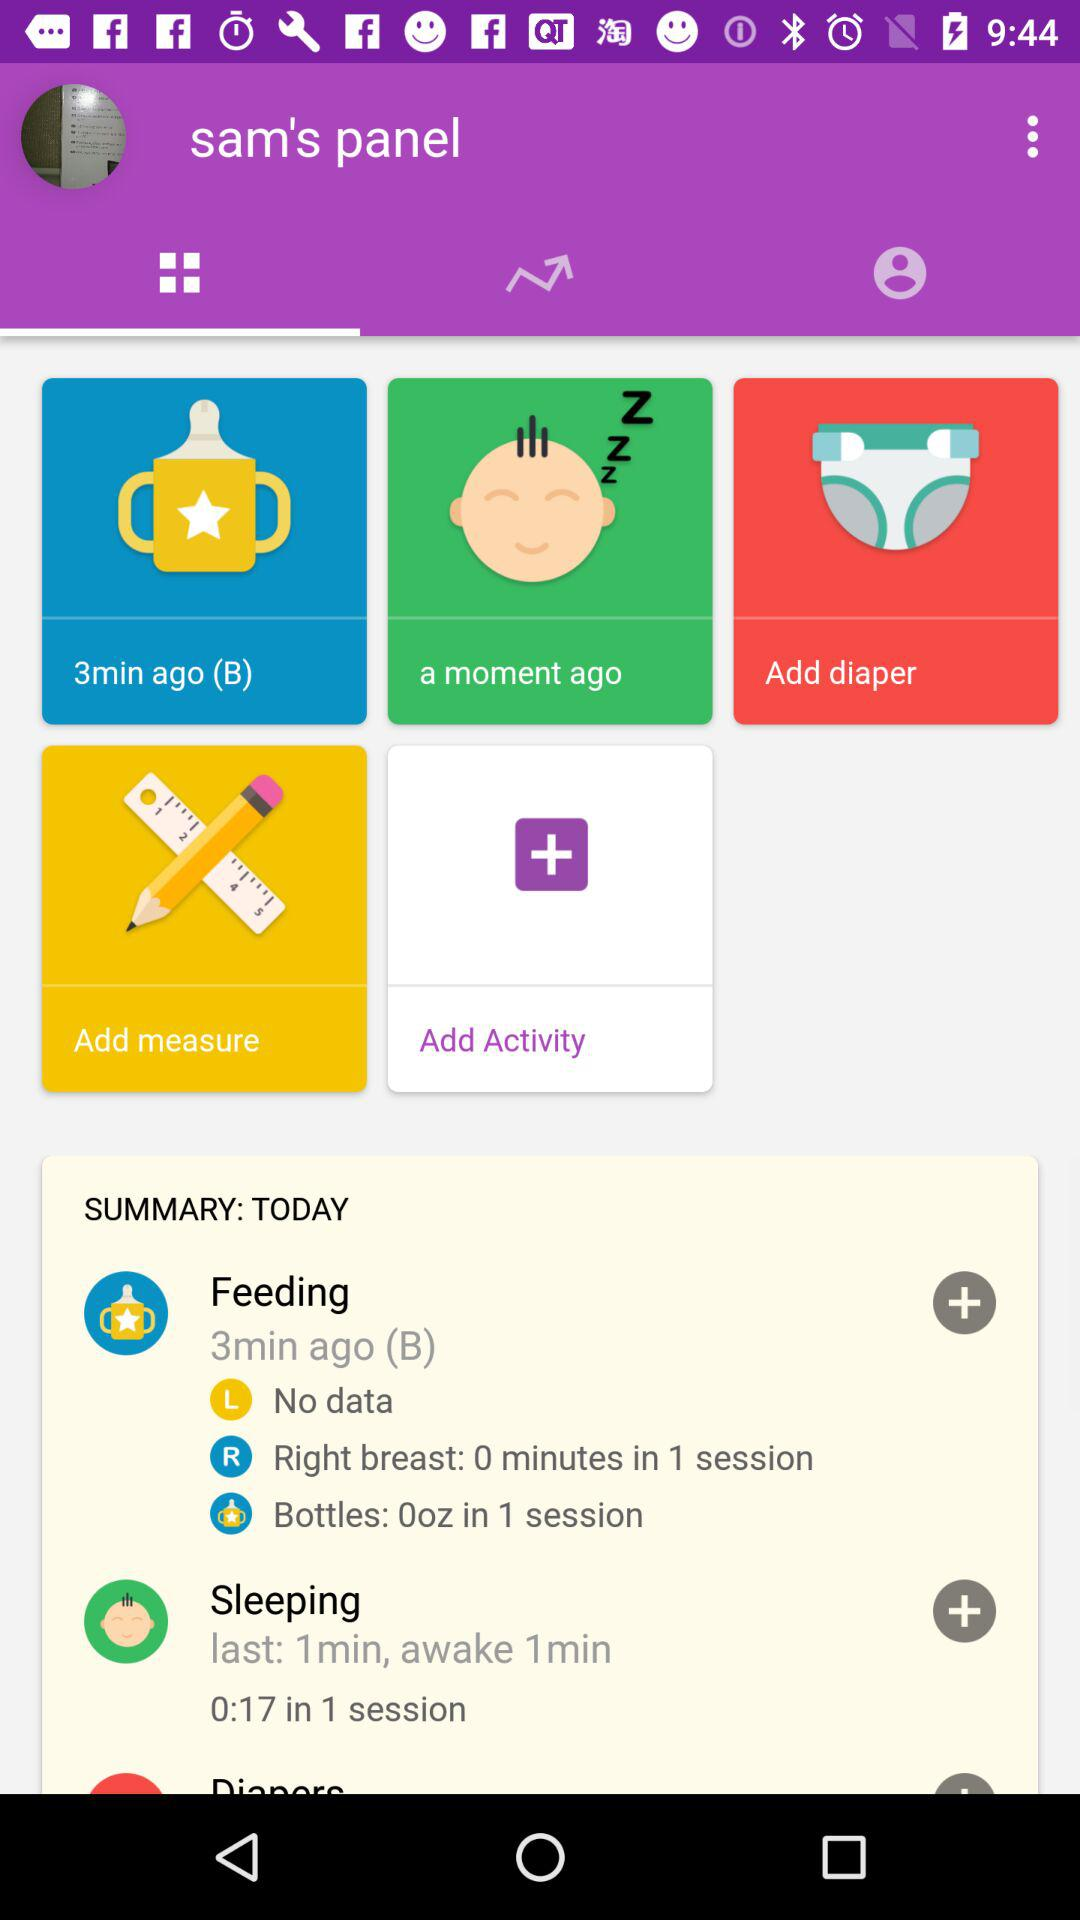What is the name of the user? The name of the user is Sam. 